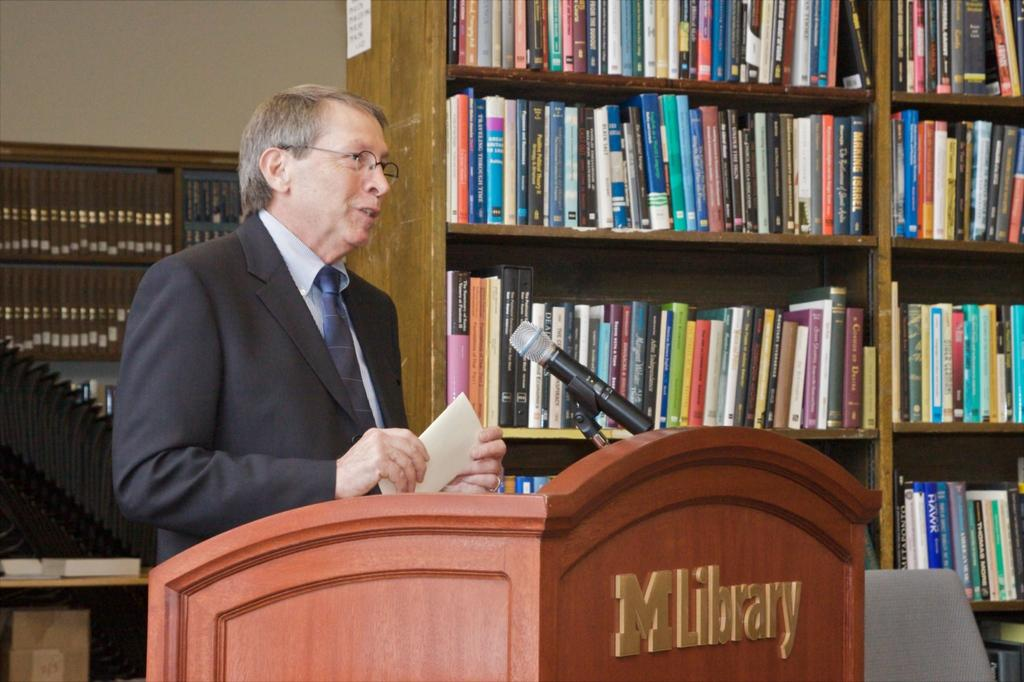<image>
Give a short and clear explanation of the subsequent image. A man stands behind a podium that says MLibrary on it. 